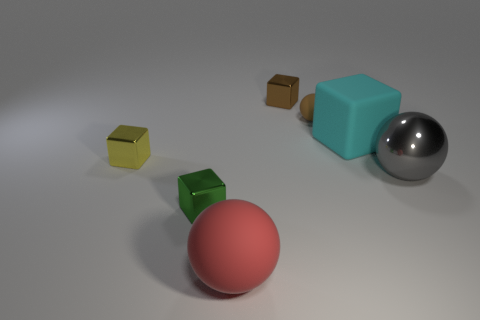What number of other objects are there of the same color as the big block?
Your answer should be compact. 0. There is a large sphere that is to the right of the large rubber thing that is in front of the big matte thing that is behind the tiny green thing; what is it made of?
Give a very brief answer. Metal. There is a small block in front of the big gray shiny object; how many shiny balls are in front of it?
Make the answer very short. 0. There is another matte object that is the same shape as the green thing; what is its color?
Make the answer very short. Cyan. Are the large cyan block and the brown block made of the same material?
Ensure brevity in your answer.  No. What number of cylinders are either red matte things or large shiny objects?
Keep it short and to the point. 0. What size is the thing behind the small brown object that is in front of the metal block behind the yellow shiny block?
Your answer should be compact. Small. What is the size of the cyan thing that is the same shape as the small green thing?
Your response must be concise. Large. How many red balls are behind the small matte thing?
Ensure brevity in your answer.  0. There is a ball on the right side of the big cyan matte block; is it the same color as the big rubber cube?
Offer a terse response. No. 